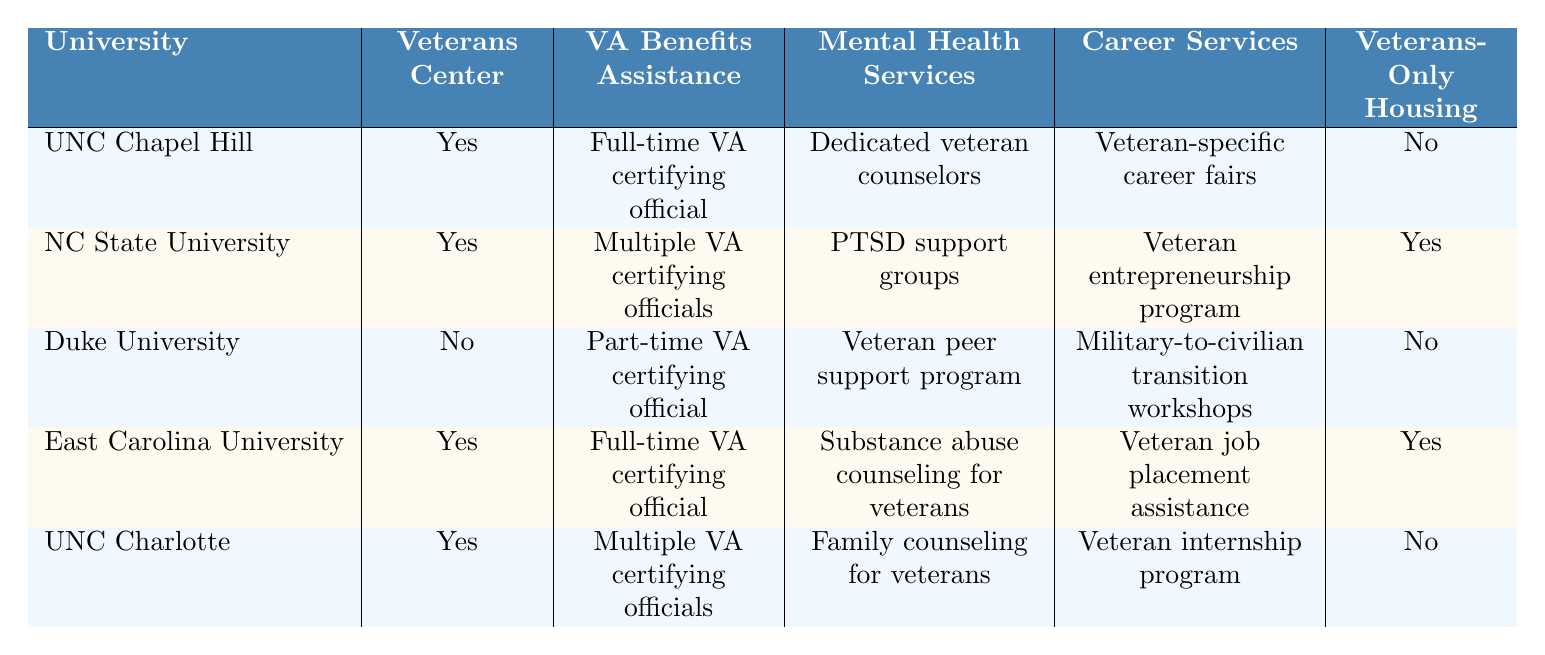What universities in North Carolina offer a Veterans Center? By examining the table, we can see that the universities with a Veterans Center are UNC Chapel Hill, NC State University, East Carolina University, and UNC Charlotte. Duke University does not have a Veterans Center.
Answer: UNC Chapel Hill, NC State University, East Carolina University, UNC Charlotte Which university has the most VA Benefits Assistance options? From the table, NC State University and UNC Charlotte both have multiple VA certifying officials, while UNC Chapel Hill and East Carolina University have one full-time official. Duke has only one part-time official. Therefore, the answer indicates that NC State and UNC Charlotte offer the most options.
Answer: NC State University, UNC Charlotte Is there veterans-only housing available at Duke University? The table indicates that Duke University has no veterans-only housing listed.
Answer: No Which university provides dedicated veteran counselors for mental health services? According to the table, UNC Chapel Hill is the only university that provides dedicated veteran counselors for mental health services.
Answer: UNC Chapel Hill How many universities provide full-time VA certifying officials? The universities that provide full-time VA certifying officials are UNC Chapel Hill, East Carolina University, and North Carolina State University. So, there are three universities in total.
Answer: 3 Do any universities offer both veterans-only housing and career services? Looking at the table, North Carolina State University and East Carolina University both offer veterans-only housing and specific career services. Thus, yes, there are two universities that provide both.
Answer: Yes Which university does not offer any veterans-specific resources related to mental health services? By reviewing the table, we see that Duke University does not have specific mental health services for veterans listed. Therefore, the answer is Duke University.
Answer: Duke University What is the total count of universities offering career services specifically targeted for veterans? The universities that offer career services specifically for veterans are UNC Chapel Hill, NC State University, East Carolina University, and UNC Charlotte, which amounts to four universities.
Answer: 4 Is there a university that specializes in veteran entrepreneurship programs? The table shows that NC State University offers a veteran entrepreneurship program, while no other university has this specialization listed in their resources.
Answer: Yes, NC State University Which university has the least amount of resources for veterans detailed in the table? Among the universities, Duke University has the least resources for veterans, as it lacks a Veterans Center and offers only a part-time VA certifying official, along with no veterans-only housing.
Answer: Duke University 